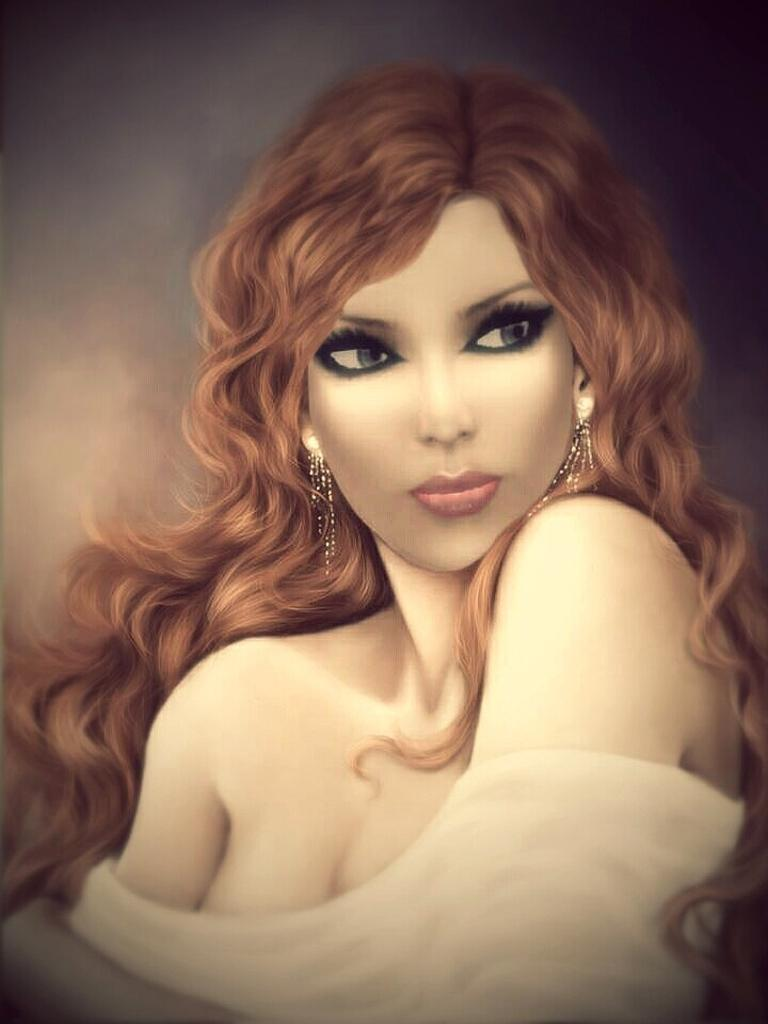What is the main subject of the image? There is a painting in the image. What does the painting depict? The painting depicts a woman. Can you describe the woman's appearance in the painting? The woman in the painting has brown hair. What type of sock is the woman wearing in the painting? There is no sock visible in the painting, as it only depicts the woman's upper body. 